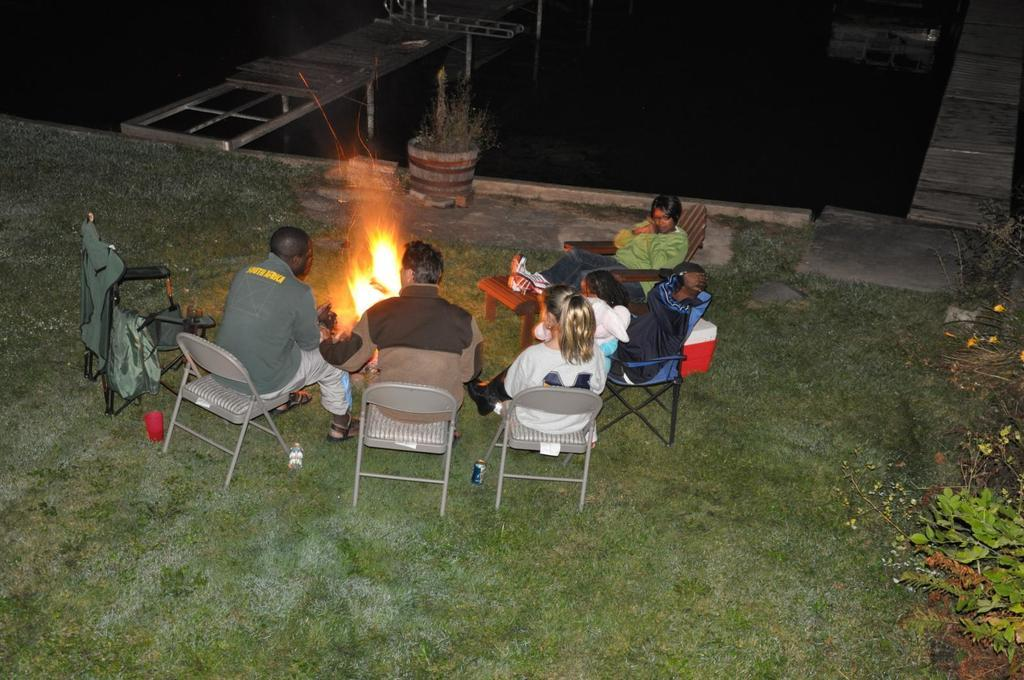What type of outdoor space is shown in the image? There is a garden in the image. What is the color of the garden? The garden is green. What are the people in the garden doing? There are people sitting on chairs in the garden. What is the color of the fire in the image? The fire is yellow. How many flocks of birds are flying over the garden in the image? There are no flocks of birds visible in the image. What type of scarf is being worn by the people sitting in the garden? There is no mention of a scarf being worn by the people in the image. 